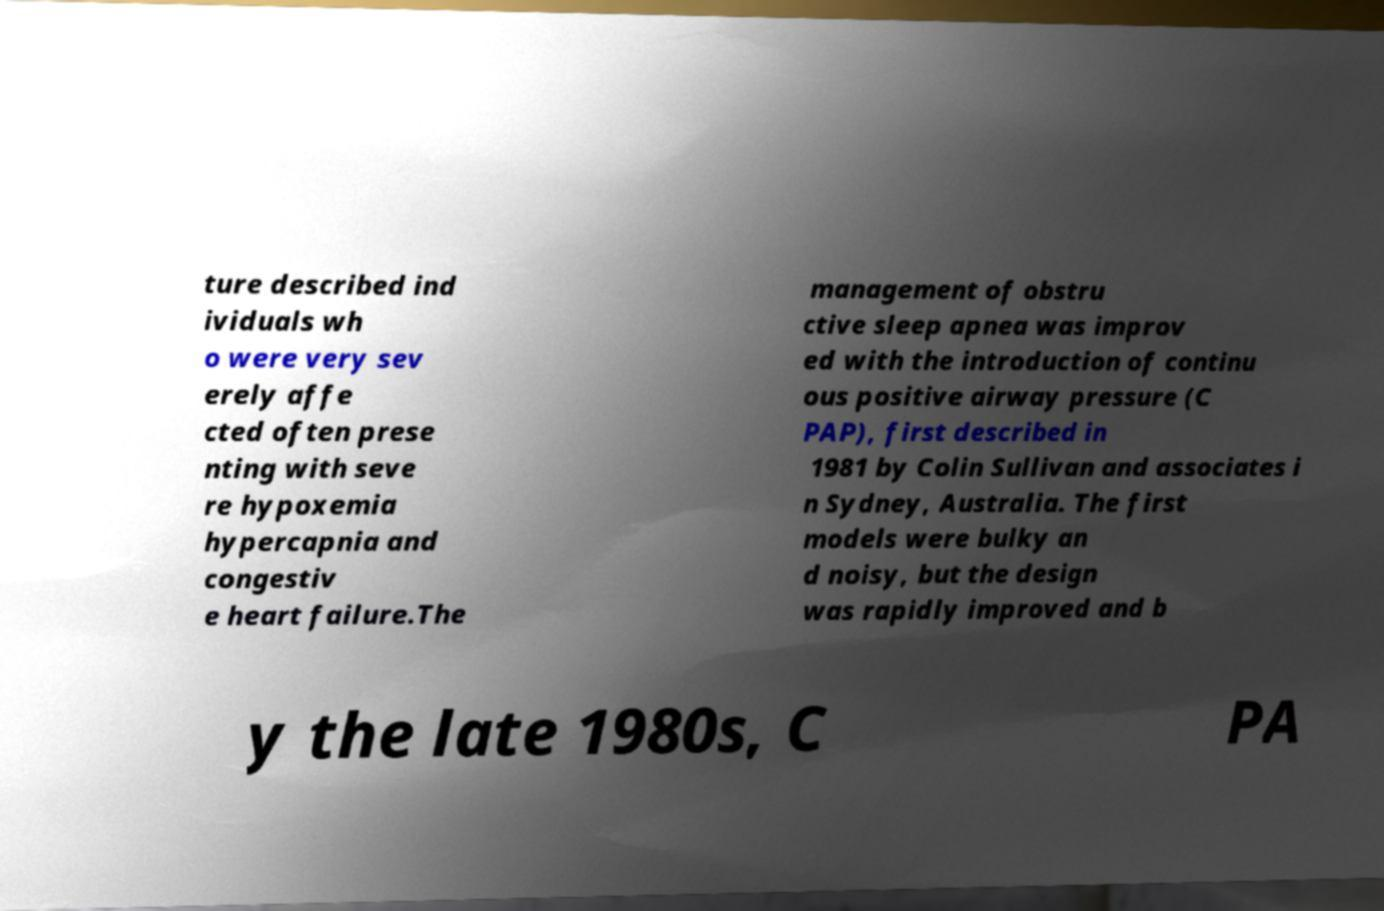Can you accurately transcribe the text from the provided image for me? ture described ind ividuals wh o were very sev erely affe cted often prese nting with seve re hypoxemia hypercapnia and congestiv e heart failure.The management of obstru ctive sleep apnea was improv ed with the introduction of continu ous positive airway pressure (C PAP), first described in 1981 by Colin Sullivan and associates i n Sydney, Australia. The first models were bulky an d noisy, but the design was rapidly improved and b y the late 1980s, C PA 